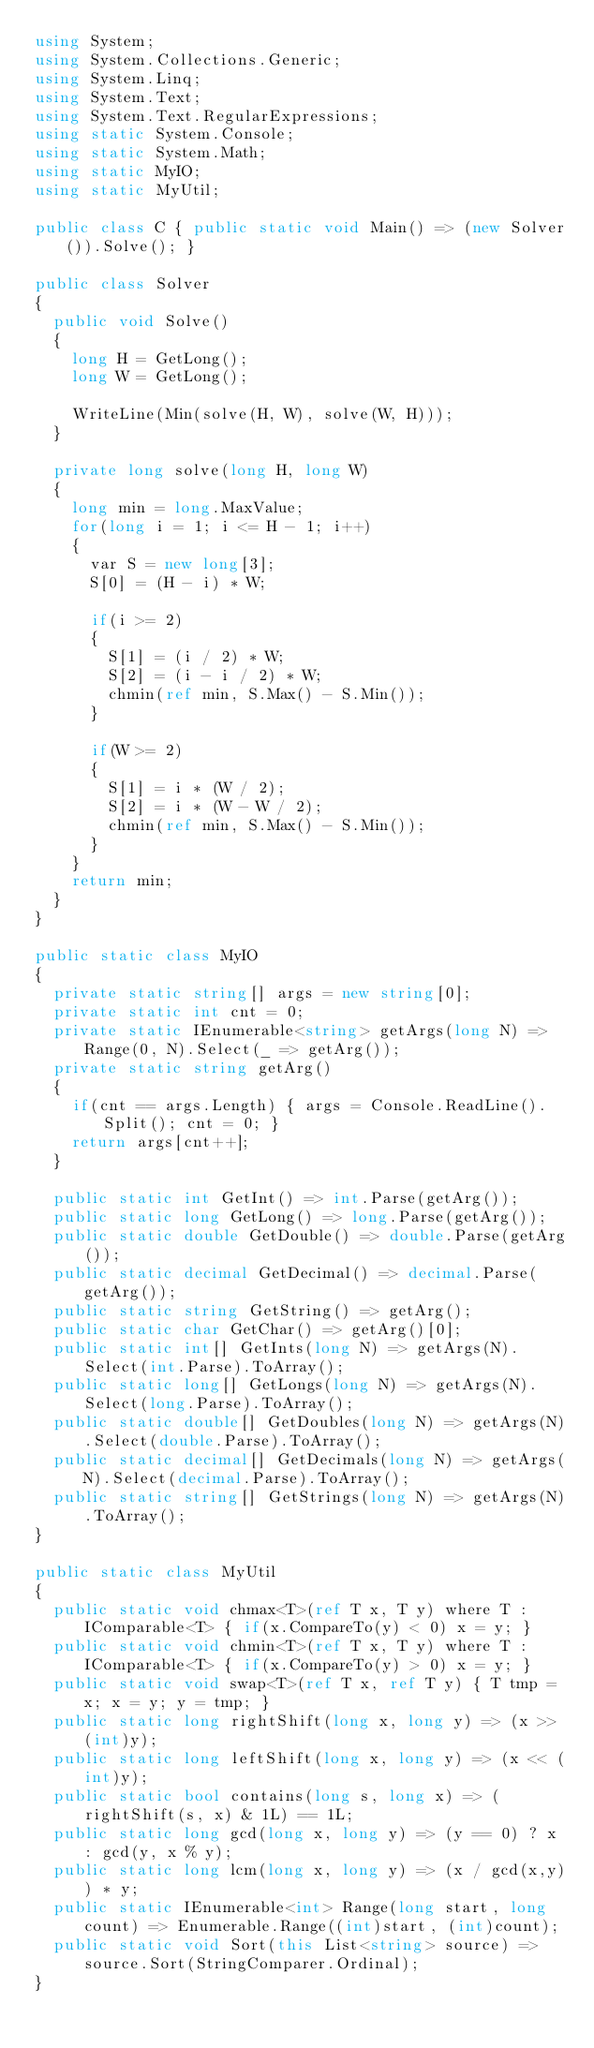Convert code to text. <code><loc_0><loc_0><loc_500><loc_500><_C#_>using System;
using System.Collections.Generic;
using System.Linq;
using System.Text;
using System.Text.RegularExpressions;
using static System.Console;
using static System.Math;
using static MyIO;
using static MyUtil;

public class C { public static void Main() => (new Solver()).Solve(); }

public class Solver
{
	public void Solve()
	{
		long H = GetLong();
		long W = GetLong();

		WriteLine(Min(solve(H, W), solve(W, H)));
	}

	private long solve(long H, long W)
	{
		long min = long.MaxValue;
		for(long i = 1; i <= H - 1; i++)
		{
			var S = new long[3];
			S[0] = (H - i) * W;

			if(i >= 2)
			{
				S[1] = (i / 2) * W;
				S[2] = (i - i / 2) * W;
				chmin(ref min, S.Max() - S.Min());
			}

			if(W >= 2)
			{
				S[1] = i * (W / 2);
				S[2] = i * (W - W / 2);
				chmin(ref min, S.Max() - S.Min());
			}			
		}
		return min;
	}
}

public static class MyIO
{
	private static string[] args = new string[0];
	private static int cnt = 0;
	private static IEnumerable<string> getArgs(long N) => Range(0, N).Select(_ => getArg());
	private static string getArg()
	{
		if(cnt == args.Length) { args = Console.ReadLine().Split(); cnt = 0; }
		return args[cnt++];
	}

	public static int GetInt() => int.Parse(getArg());
	public static long GetLong() => long.Parse(getArg());
	public static double GetDouble() => double.Parse(getArg());
	public static decimal GetDecimal() => decimal.Parse(getArg());
	public static string GetString() => getArg();
	public static char GetChar() => getArg()[0];
	public static int[] GetInts(long N) => getArgs(N).Select(int.Parse).ToArray();
	public static long[] GetLongs(long N) => getArgs(N).Select(long.Parse).ToArray();
	public static double[] GetDoubles(long N) => getArgs(N).Select(double.Parse).ToArray();
	public static decimal[] GetDecimals(long N) => getArgs(N).Select(decimal.Parse).ToArray();
	public static string[] GetStrings(long N) => getArgs(N).ToArray();
}

public static class MyUtil
{
	public static void chmax<T>(ref T x, T y) where T : IComparable<T> { if(x.CompareTo(y) < 0) x = y; }
	public static void chmin<T>(ref T x, T y) where T : IComparable<T> { if(x.CompareTo(y) > 0)	x = y; }
	public static void swap<T>(ref T x, ref T y) { T tmp = x; x = y; y = tmp; }
	public static long rightShift(long x, long y) => (x >> (int)y);
	public static long leftShift(long x, long y) => (x << (int)y);
	public static bool contains(long s, long x) => (rightShift(s, x) & 1L) == 1L;
	public static long gcd(long x, long y) => (y == 0) ? x : gcd(y, x % y);
	public static long lcm(long x, long y) => (x / gcd(x,y)) * y;	
	public static IEnumerable<int> Range(long start, long count) => Enumerable.Range((int)start, (int)count);
	public static void Sort(this List<string> source) => source.Sort(StringComparer.Ordinal);
}
</code> 